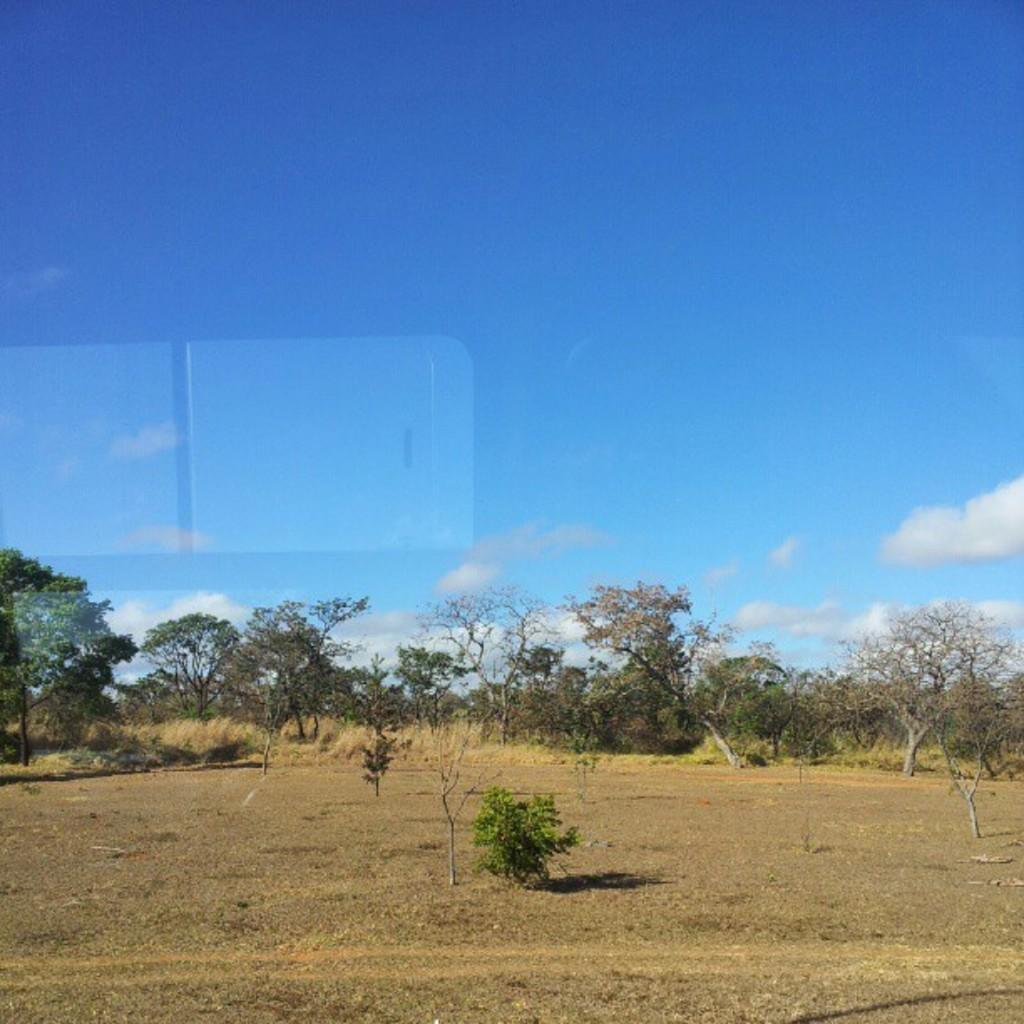What type of vegetation can be seen at the bottom of the image? There are trees and plants at the bottom of the image. What is visible at the top of the image? There is a sky visible at the top of the image. What can be observed in the sky? Clouds are present in the sky. Where is the faucet located in the image? There is no faucet present in the image. How does the stove contribute to the comfort in the image? There is no stove present in the image, so it cannot contribute to the comfort. 